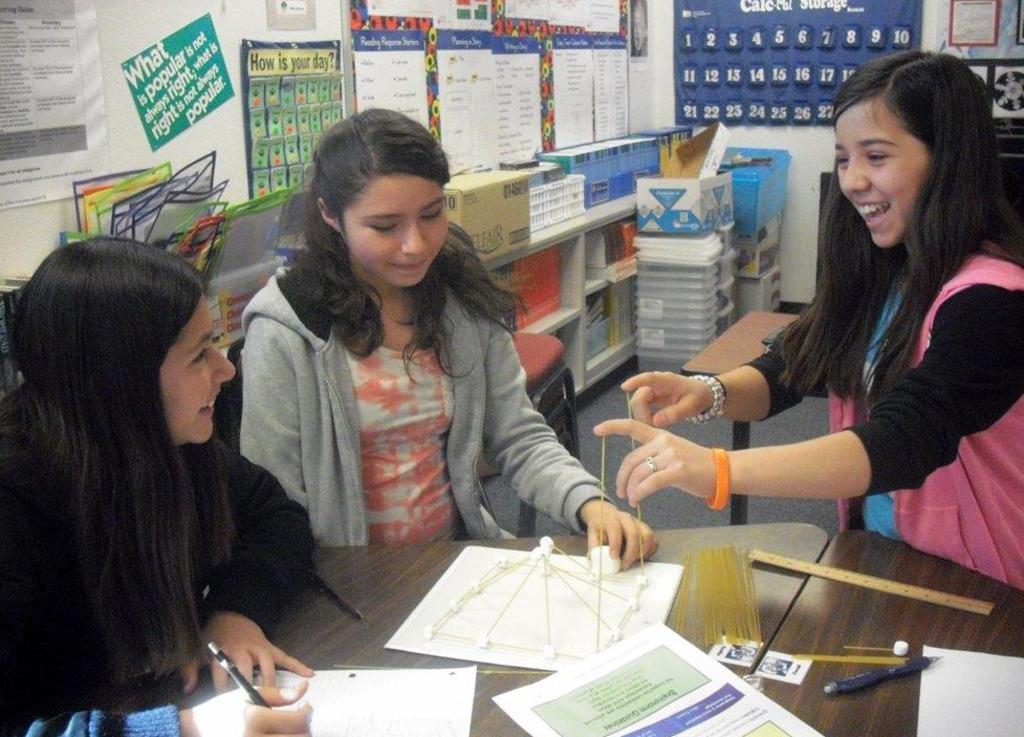Please provide a concise description of this image. This image consists of three girls. In the middle, there is a table on which there are many papers and papers. In the background, there is a wall on which there are charts and poster pasted. At the bottom, there is a floor. 